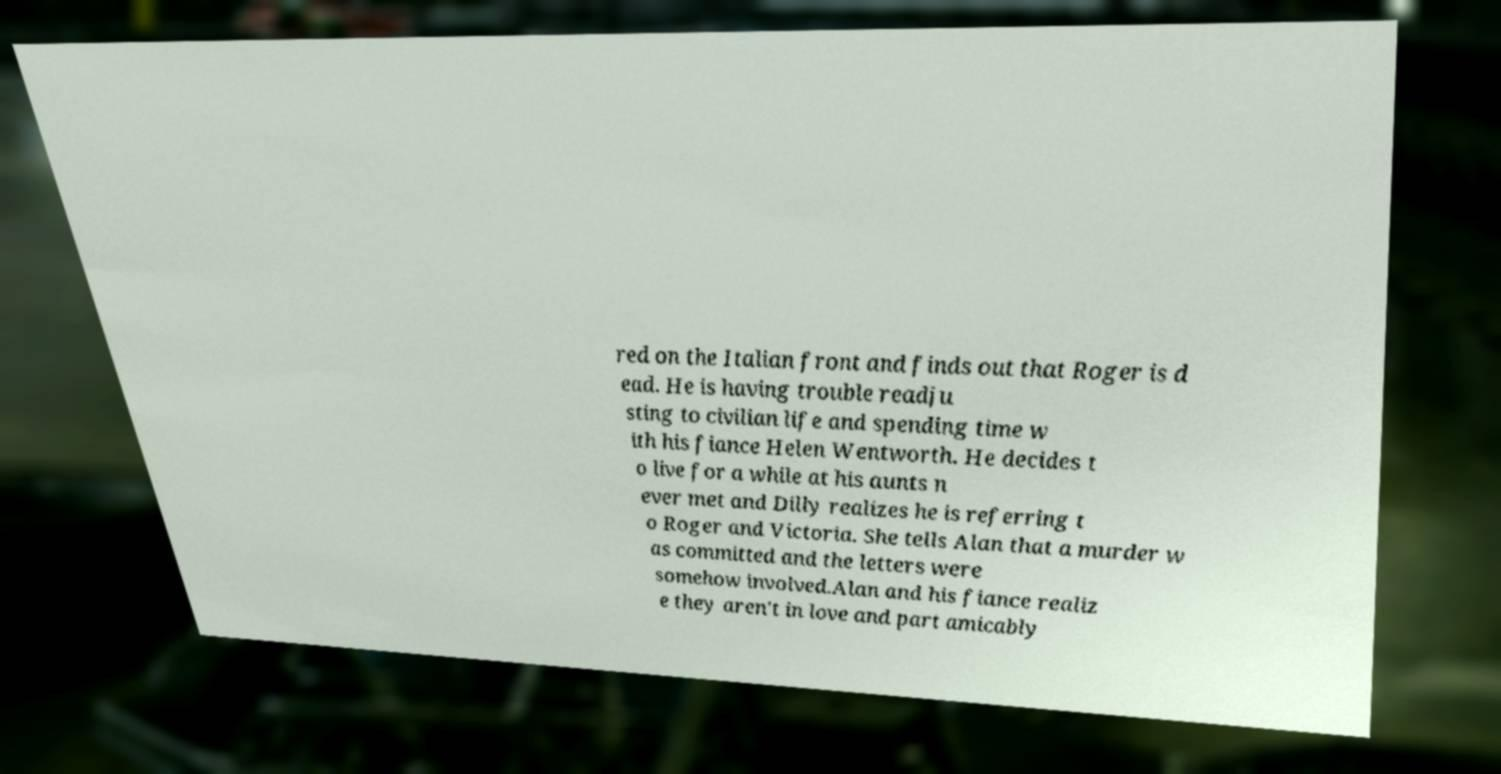For documentation purposes, I need the text within this image transcribed. Could you provide that? red on the Italian front and finds out that Roger is d ead. He is having trouble readju sting to civilian life and spending time w ith his fiance Helen Wentworth. He decides t o live for a while at his aunts n ever met and Dilly realizes he is referring t o Roger and Victoria. She tells Alan that a murder w as committed and the letters were somehow involved.Alan and his fiance realiz e they aren't in love and part amicably 